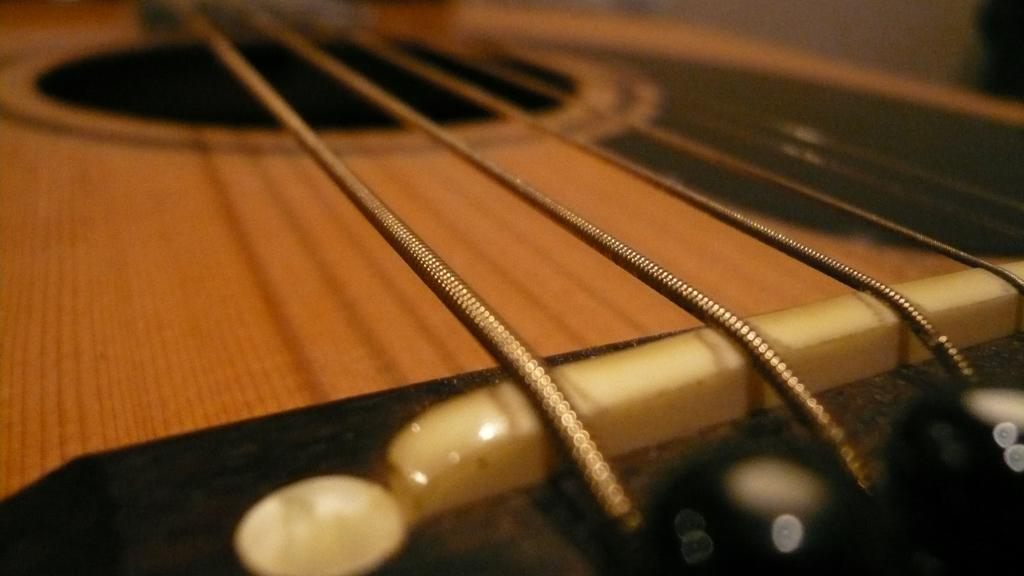What type of objects are present in the image? There are musical instruments in the image. What feature do the musical instruments have in common? The musical instruments have strings. What material are the musical instruments made of? The musical instruments are made of wooden material. What type of jar is visible on the trip in the image? There is no jar or trip present in the image; it features musical instruments made of wooden material with strings. 